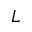Convert formula to latex. <formula><loc_0><loc_0><loc_500><loc_500>L</formula> 